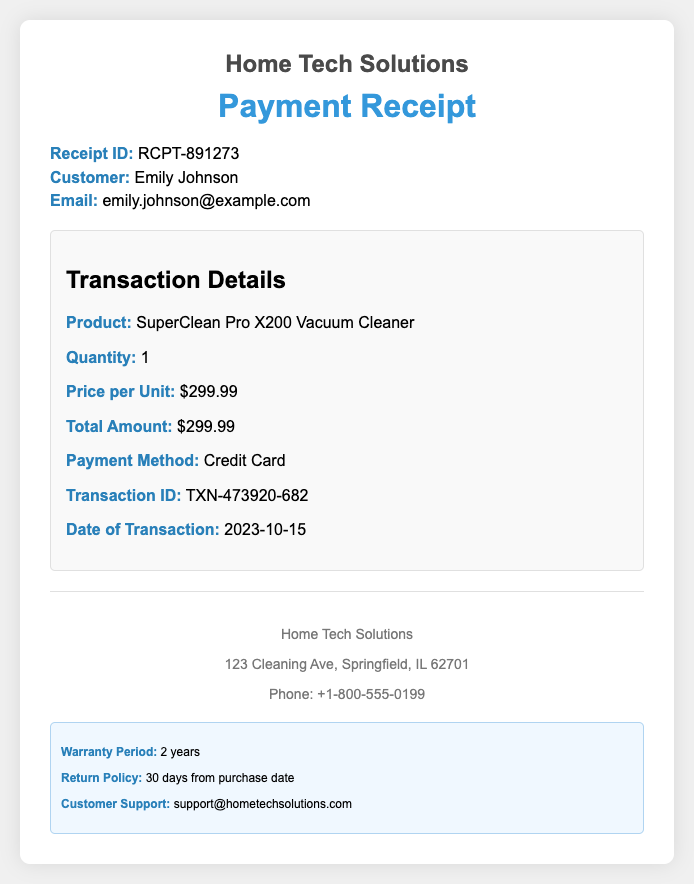What is the receipt ID? The receipt ID is specified in the document, which is RCPT-891273.
Answer: RCPT-891273 Who is the customer? The name of the customer is mentioned in the document, which is Emily Johnson.
Answer: Emily Johnson What is the payment method? The payment method used for the transaction is indicated in the document, which is Credit Card.
Answer: Credit Card What is the transaction ID? The transaction ID is provided in the document, listed as TXN-473920-682.
Answer: TXN-473920-682 When was the transaction made? The date of the transaction is specified in the document as 2023-10-15.
Answer: 2023-10-15 What was the price per unit? The document specifies the price per unit of the product, which is $299.99.
Answer: $299.99 What is the total amount charged? The total amount for the transaction is outlined in the document, which is $299.99.
Answer: $299.99 What is the warranty period? The warranty period mentioned in the document is 2 years.
Answer: 2 years What is the return policy duration? The return policy duration is indicated in the document as 30 days from purchase date.
Answer: 30 days from purchase date 